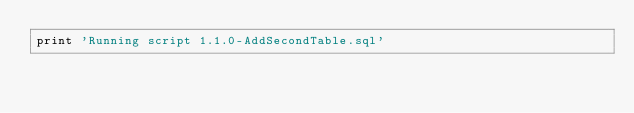<code> <loc_0><loc_0><loc_500><loc_500><_SQL_>print 'Running script 1.1.0-AddSecondTable.sql'</code> 